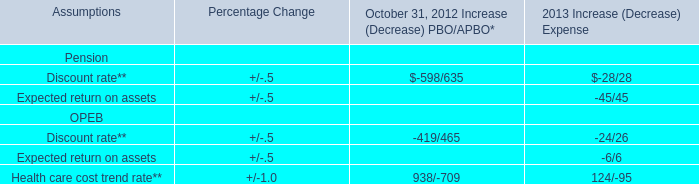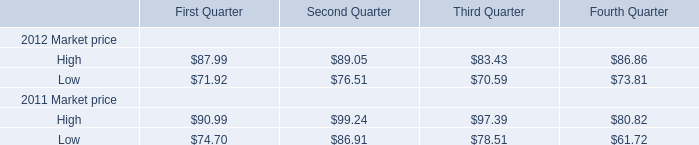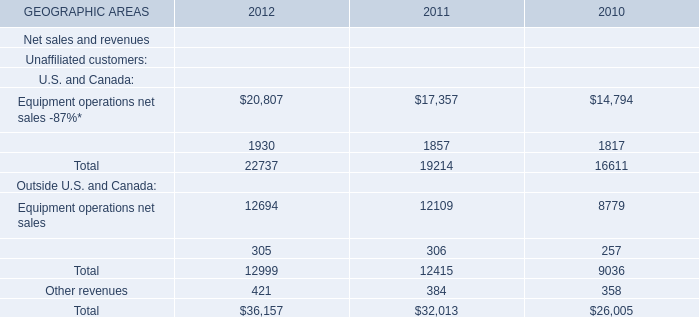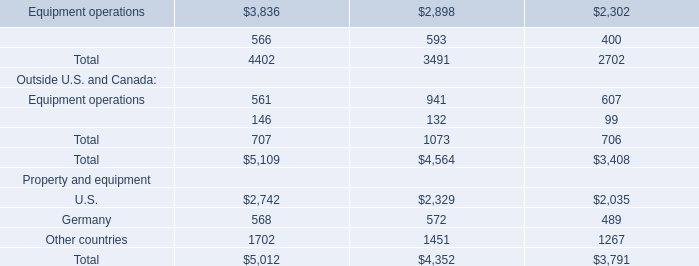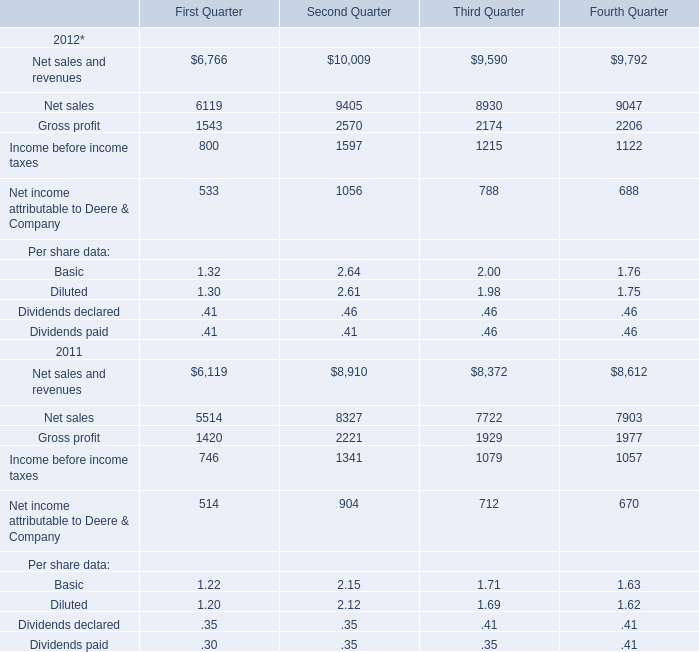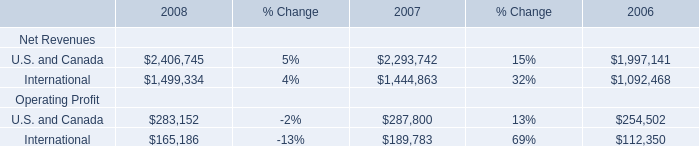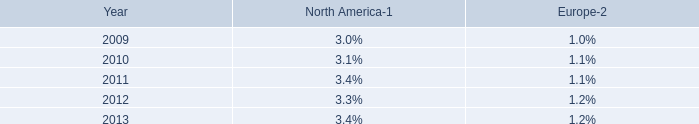In the year with largest amount of High Market Price in Fourth Quarter, what's the increasing rate of Low Market Price in Fourth Quarter? 
Computations: ((73.81 - 61.72) / 61.72)
Answer: 0.19588. 